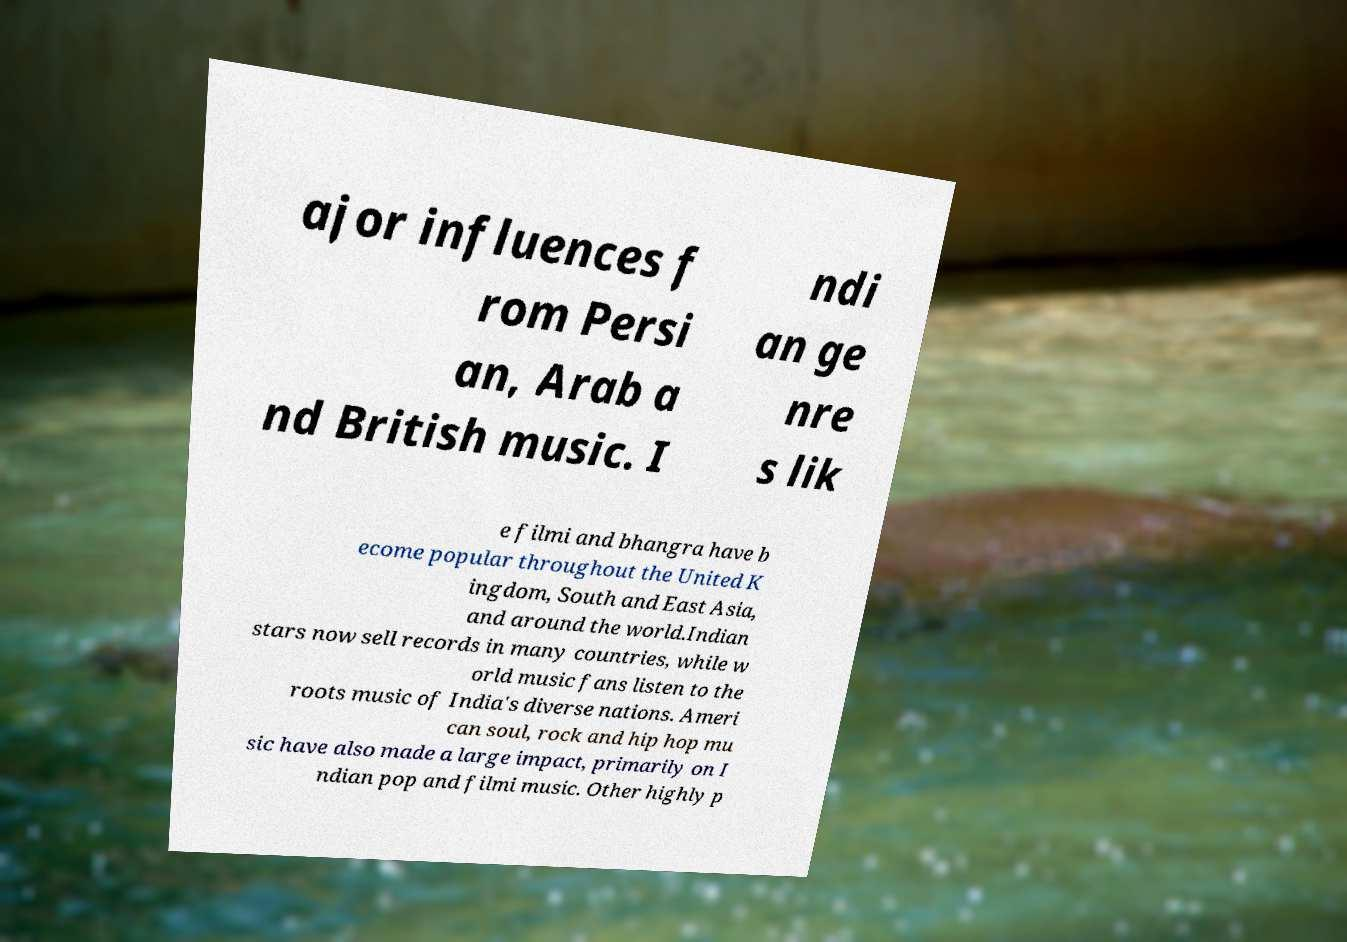Can you accurately transcribe the text from the provided image for me? ajor influences f rom Persi an, Arab a nd British music. I ndi an ge nre s lik e filmi and bhangra have b ecome popular throughout the United K ingdom, South and East Asia, and around the world.Indian stars now sell records in many countries, while w orld music fans listen to the roots music of India's diverse nations. Ameri can soul, rock and hip hop mu sic have also made a large impact, primarily on I ndian pop and filmi music. Other highly p 